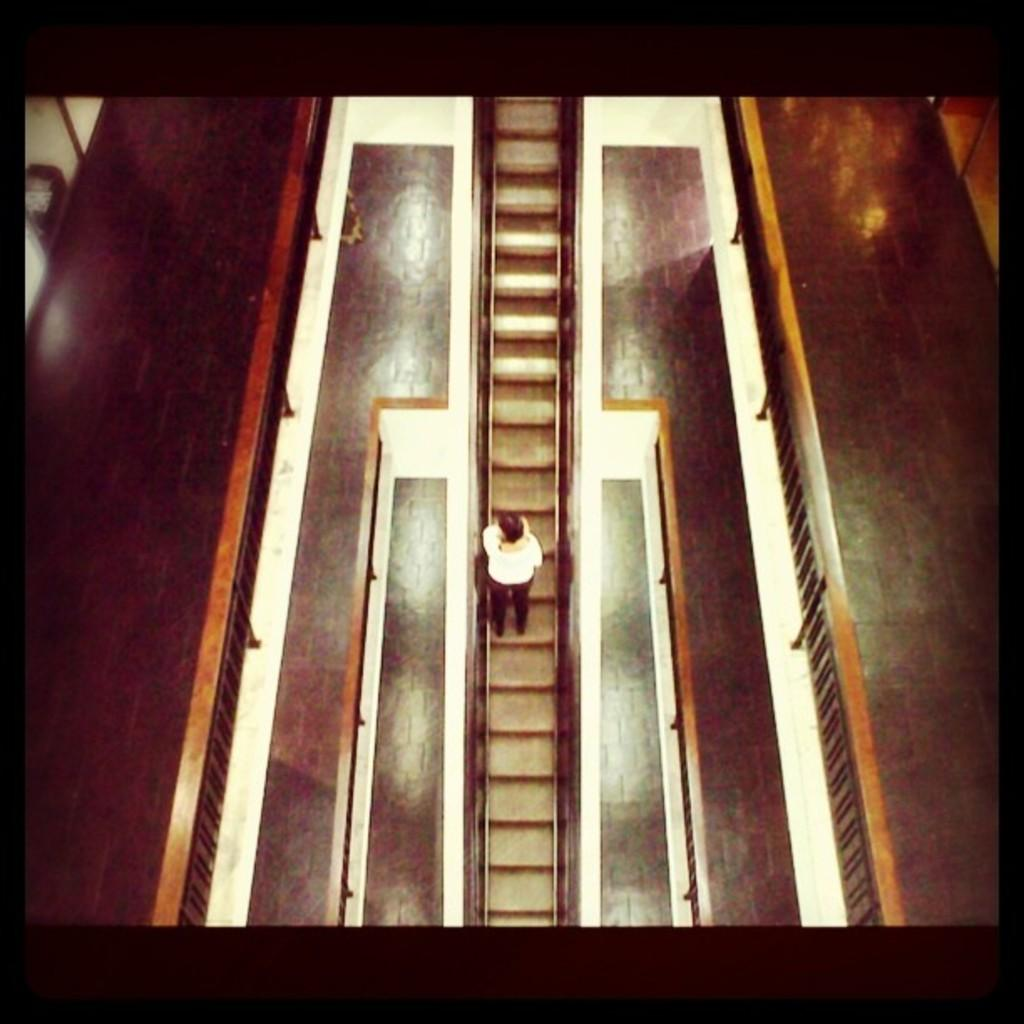What is the main subject of the image? There is a picture in the image. What is depicted in the picture? The picture contains a man. Where is the man located in the picture? The man is on a staircase. How many giants can be seen interacting with the man on the staircase in the image? There are no giants present in the image; it only features a man on a staircase. What type of celery is visible in the image? There is no celery present in the image. 